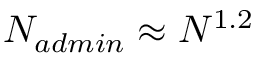Convert formula to latex. <formula><loc_0><loc_0><loc_500><loc_500>N _ { a d \min } \approx N ^ { 1 . 2 }</formula> 